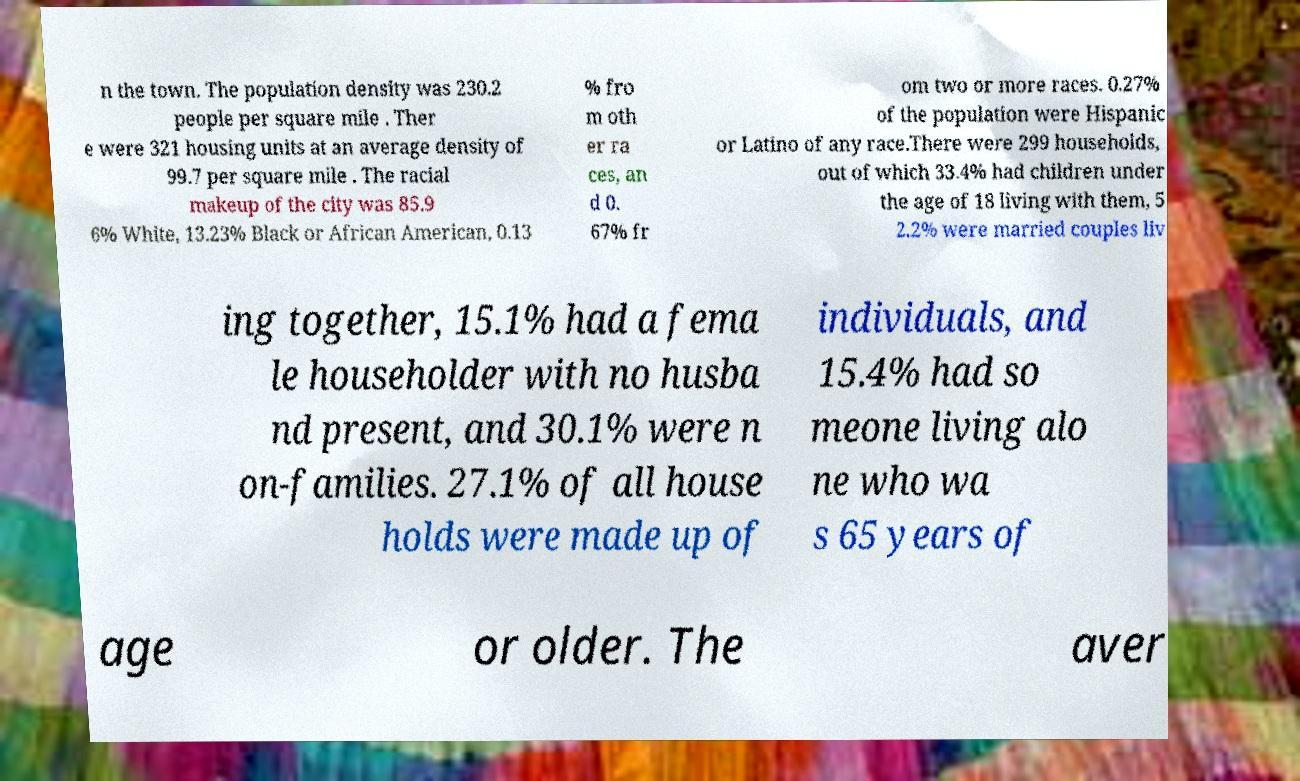I need the written content from this picture converted into text. Can you do that? n the town. The population density was 230.2 people per square mile . Ther e were 321 housing units at an average density of 99.7 per square mile . The racial makeup of the city was 85.9 6% White, 13.23% Black or African American, 0.13 % fro m oth er ra ces, an d 0. 67% fr om two or more races. 0.27% of the population were Hispanic or Latino of any race.There were 299 households, out of which 33.4% had children under the age of 18 living with them, 5 2.2% were married couples liv ing together, 15.1% had a fema le householder with no husba nd present, and 30.1% were n on-families. 27.1% of all house holds were made up of individuals, and 15.4% had so meone living alo ne who wa s 65 years of age or older. The aver 